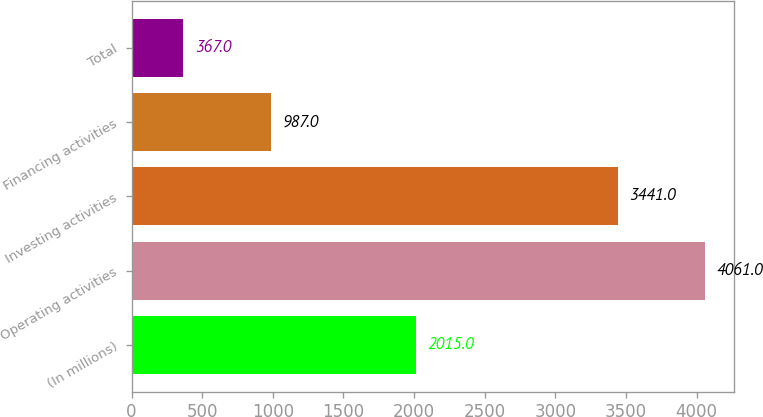Convert chart. <chart><loc_0><loc_0><loc_500><loc_500><bar_chart><fcel>(In millions)<fcel>Operating activities<fcel>Investing activities<fcel>Financing activities<fcel>Total<nl><fcel>2015<fcel>4061<fcel>3441<fcel>987<fcel>367<nl></chart> 